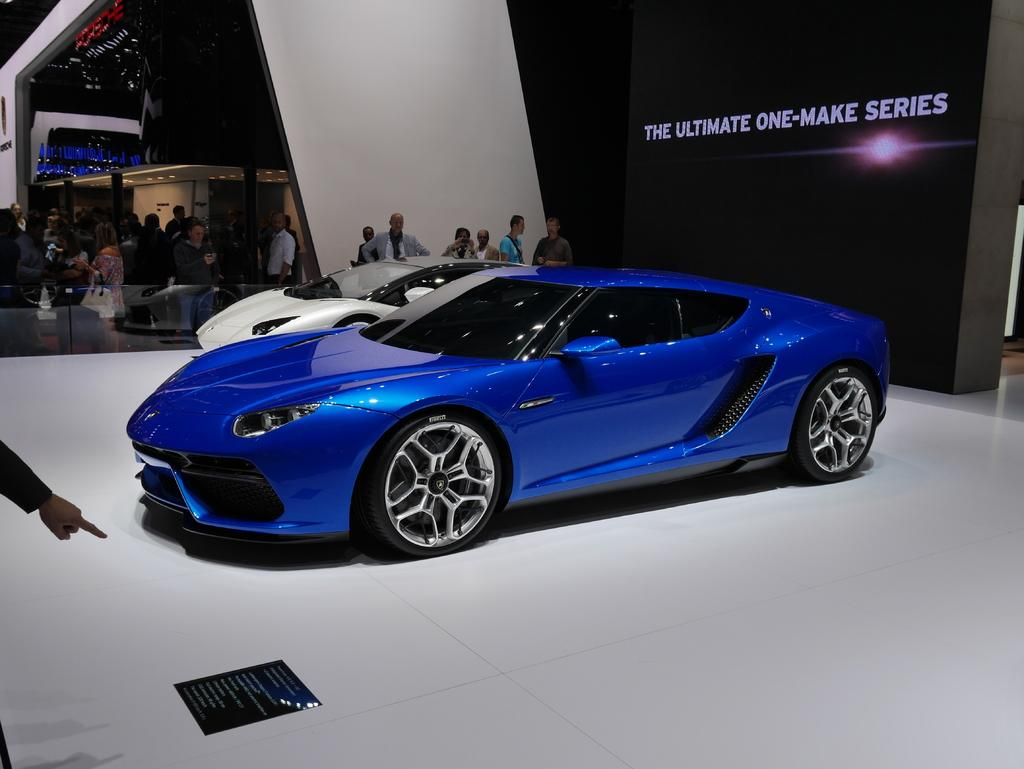What objects are on the floor in the image? There are cars on the floor in the image. What can be seen in the background of the image? There are people standing and an architecture in the background of the image. What is present on the board in the image? There is a board with text in the image. What type of juice is being served at the meeting in the image? There is no meeting or juice present in the image. 